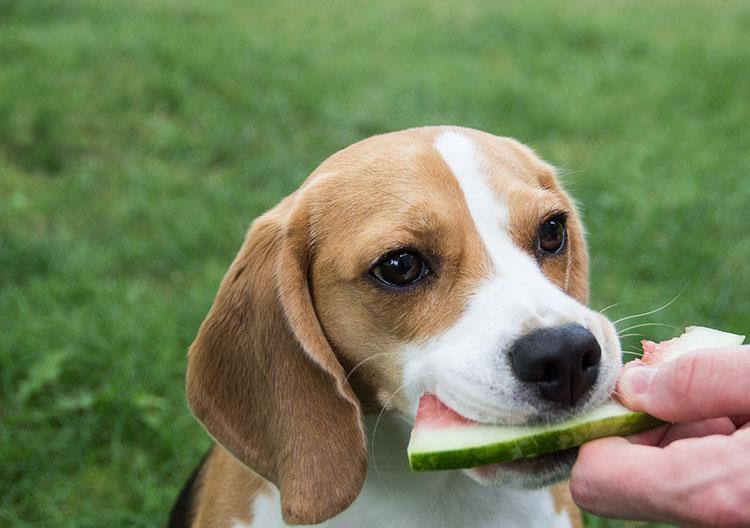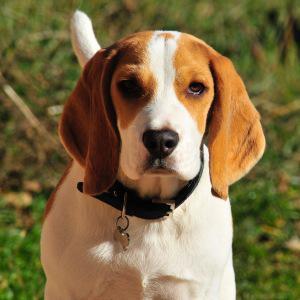The first image is the image on the left, the second image is the image on the right. Assess this claim about the two images: "At least one dog wears something around his neck.". Correct or not? Answer yes or no. Yes. 